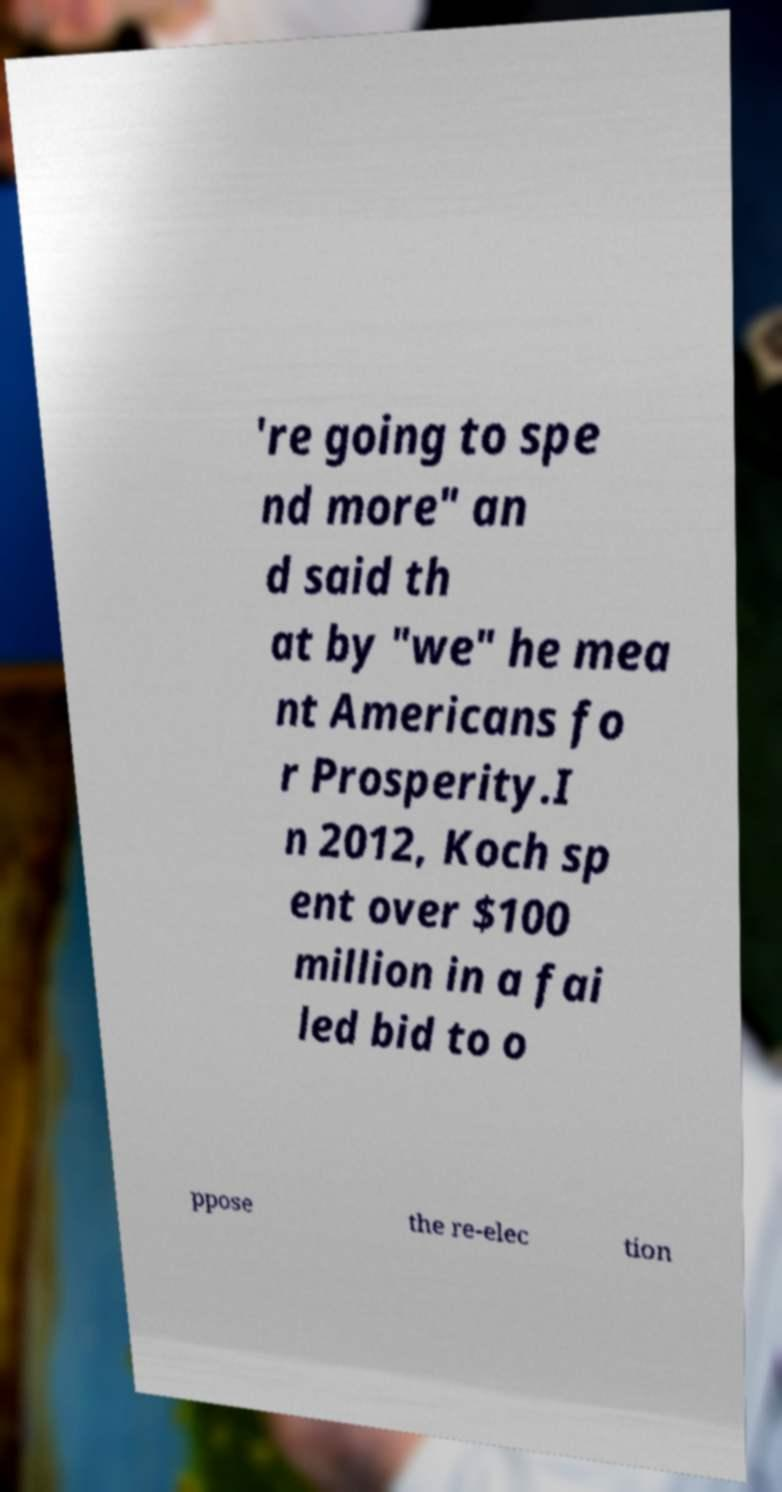There's text embedded in this image that I need extracted. Can you transcribe it verbatim? 're going to spe nd more" an d said th at by "we" he mea nt Americans fo r Prosperity.I n 2012, Koch sp ent over $100 million in a fai led bid to o ppose the re-elec tion 